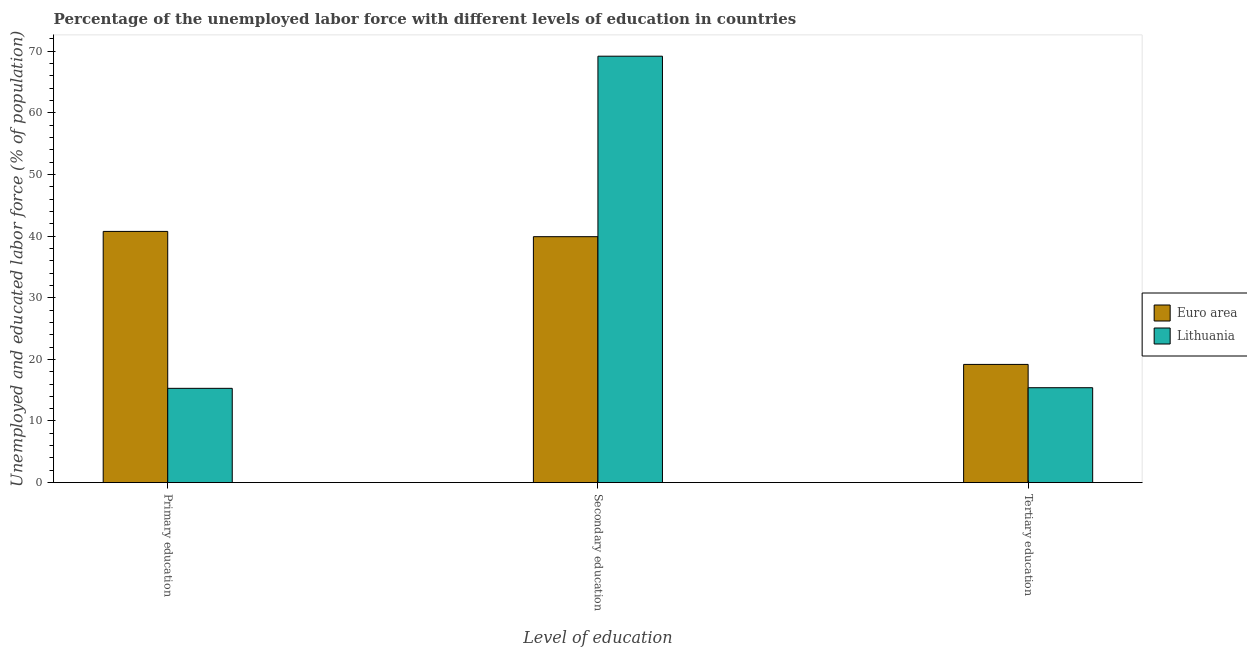How many different coloured bars are there?
Your answer should be compact. 2. How many bars are there on the 3rd tick from the left?
Make the answer very short. 2. How many bars are there on the 1st tick from the right?
Make the answer very short. 2. What is the label of the 2nd group of bars from the left?
Your answer should be compact. Secondary education. What is the percentage of labor force who received tertiary education in Lithuania?
Offer a very short reply. 15.4. Across all countries, what is the maximum percentage of labor force who received primary education?
Keep it short and to the point. 40.77. Across all countries, what is the minimum percentage of labor force who received tertiary education?
Provide a succinct answer. 15.4. In which country was the percentage of labor force who received secondary education maximum?
Your answer should be very brief. Lithuania. What is the total percentage of labor force who received secondary education in the graph?
Make the answer very short. 109.11. What is the difference between the percentage of labor force who received secondary education in Euro area and that in Lithuania?
Make the answer very short. -29.29. What is the difference between the percentage of labor force who received primary education in Lithuania and the percentage of labor force who received secondary education in Euro area?
Offer a very short reply. -24.61. What is the average percentage of labor force who received secondary education per country?
Your response must be concise. 54.56. What is the difference between the percentage of labor force who received secondary education and percentage of labor force who received primary education in Lithuania?
Your answer should be very brief. 53.9. What is the ratio of the percentage of labor force who received primary education in Euro area to that in Lithuania?
Give a very brief answer. 2.66. What is the difference between the highest and the second highest percentage of labor force who received primary education?
Offer a terse response. 25.47. What is the difference between the highest and the lowest percentage of labor force who received primary education?
Provide a short and direct response. 25.47. In how many countries, is the percentage of labor force who received secondary education greater than the average percentage of labor force who received secondary education taken over all countries?
Keep it short and to the point. 1. Is the sum of the percentage of labor force who received primary education in Lithuania and Euro area greater than the maximum percentage of labor force who received secondary education across all countries?
Offer a terse response. No. What does the 2nd bar from the left in Primary education represents?
Your answer should be very brief. Lithuania. What does the 1st bar from the right in Tertiary education represents?
Provide a short and direct response. Lithuania. How many countries are there in the graph?
Ensure brevity in your answer.  2. Does the graph contain any zero values?
Offer a very short reply. No. Where does the legend appear in the graph?
Offer a very short reply. Center right. How many legend labels are there?
Your answer should be very brief. 2. How are the legend labels stacked?
Give a very brief answer. Vertical. What is the title of the graph?
Give a very brief answer. Percentage of the unemployed labor force with different levels of education in countries. Does "High income" appear as one of the legend labels in the graph?
Provide a succinct answer. No. What is the label or title of the X-axis?
Provide a short and direct response. Level of education. What is the label or title of the Y-axis?
Provide a succinct answer. Unemployed and educated labor force (% of population). What is the Unemployed and educated labor force (% of population) in Euro area in Primary education?
Ensure brevity in your answer.  40.77. What is the Unemployed and educated labor force (% of population) of Lithuania in Primary education?
Offer a terse response. 15.3. What is the Unemployed and educated labor force (% of population) in Euro area in Secondary education?
Offer a terse response. 39.91. What is the Unemployed and educated labor force (% of population) in Lithuania in Secondary education?
Ensure brevity in your answer.  69.2. What is the Unemployed and educated labor force (% of population) in Euro area in Tertiary education?
Provide a short and direct response. 19.18. What is the Unemployed and educated labor force (% of population) in Lithuania in Tertiary education?
Give a very brief answer. 15.4. Across all Level of education, what is the maximum Unemployed and educated labor force (% of population) in Euro area?
Make the answer very short. 40.77. Across all Level of education, what is the maximum Unemployed and educated labor force (% of population) of Lithuania?
Provide a succinct answer. 69.2. Across all Level of education, what is the minimum Unemployed and educated labor force (% of population) in Euro area?
Offer a very short reply. 19.18. Across all Level of education, what is the minimum Unemployed and educated labor force (% of population) in Lithuania?
Your answer should be compact. 15.3. What is the total Unemployed and educated labor force (% of population) in Euro area in the graph?
Give a very brief answer. 99.86. What is the total Unemployed and educated labor force (% of population) in Lithuania in the graph?
Provide a succinct answer. 99.9. What is the difference between the Unemployed and educated labor force (% of population) of Euro area in Primary education and that in Secondary education?
Offer a terse response. 0.85. What is the difference between the Unemployed and educated labor force (% of population) of Lithuania in Primary education and that in Secondary education?
Your response must be concise. -53.9. What is the difference between the Unemployed and educated labor force (% of population) in Euro area in Primary education and that in Tertiary education?
Make the answer very short. 21.58. What is the difference between the Unemployed and educated labor force (% of population) of Lithuania in Primary education and that in Tertiary education?
Make the answer very short. -0.1. What is the difference between the Unemployed and educated labor force (% of population) of Euro area in Secondary education and that in Tertiary education?
Provide a succinct answer. 20.73. What is the difference between the Unemployed and educated labor force (% of population) of Lithuania in Secondary education and that in Tertiary education?
Keep it short and to the point. 53.8. What is the difference between the Unemployed and educated labor force (% of population) of Euro area in Primary education and the Unemployed and educated labor force (% of population) of Lithuania in Secondary education?
Provide a short and direct response. -28.43. What is the difference between the Unemployed and educated labor force (% of population) in Euro area in Primary education and the Unemployed and educated labor force (% of population) in Lithuania in Tertiary education?
Ensure brevity in your answer.  25.37. What is the difference between the Unemployed and educated labor force (% of population) in Euro area in Secondary education and the Unemployed and educated labor force (% of population) in Lithuania in Tertiary education?
Keep it short and to the point. 24.51. What is the average Unemployed and educated labor force (% of population) in Euro area per Level of education?
Your answer should be very brief. 33.29. What is the average Unemployed and educated labor force (% of population) of Lithuania per Level of education?
Give a very brief answer. 33.3. What is the difference between the Unemployed and educated labor force (% of population) of Euro area and Unemployed and educated labor force (% of population) of Lithuania in Primary education?
Provide a succinct answer. 25.47. What is the difference between the Unemployed and educated labor force (% of population) in Euro area and Unemployed and educated labor force (% of population) in Lithuania in Secondary education?
Provide a succinct answer. -29.29. What is the difference between the Unemployed and educated labor force (% of population) in Euro area and Unemployed and educated labor force (% of population) in Lithuania in Tertiary education?
Provide a short and direct response. 3.78. What is the ratio of the Unemployed and educated labor force (% of population) in Euro area in Primary education to that in Secondary education?
Your response must be concise. 1.02. What is the ratio of the Unemployed and educated labor force (% of population) in Lithuania in Primary education to that in Secondary education?
Ensure brevity in your answer.  0.22. What is the ratio of the Unemployed and educated labor force (% of population) in Euro area in Primary education to that in Tertiary education?
Keep it short and to the point. 2.13. What is the ratio of the Unemployed and educated labor force (% of population) of Euro area in Secondary education to that in Tertiary education?
Provide a succinct answer. 2.08. What is the ratio of the Unemployed and educated labor force (% of population) in Lithuania in Secondary education to that in Tertiary education?
Your answer should be very brief. 4.49. What is the difference between the highest and the second highest Unemployed and educated labor force (% of population) of Euro area?
Make the answer very short. 0.85. What is the difference between the highest and the second highest Unemployed and educated labor force (% of population) in Lithuania?
Offer a terse response. 53.8. What is the difference between the highest and the lowest Unemployed and educated labor force (% of population) in Euro area?
Offer a very short reply. 21.58. What is the difference between the highest and the lowest Unemployed and educated labor force (% of population) in Lithuania?
Keep it short and to the point. 53.9. 